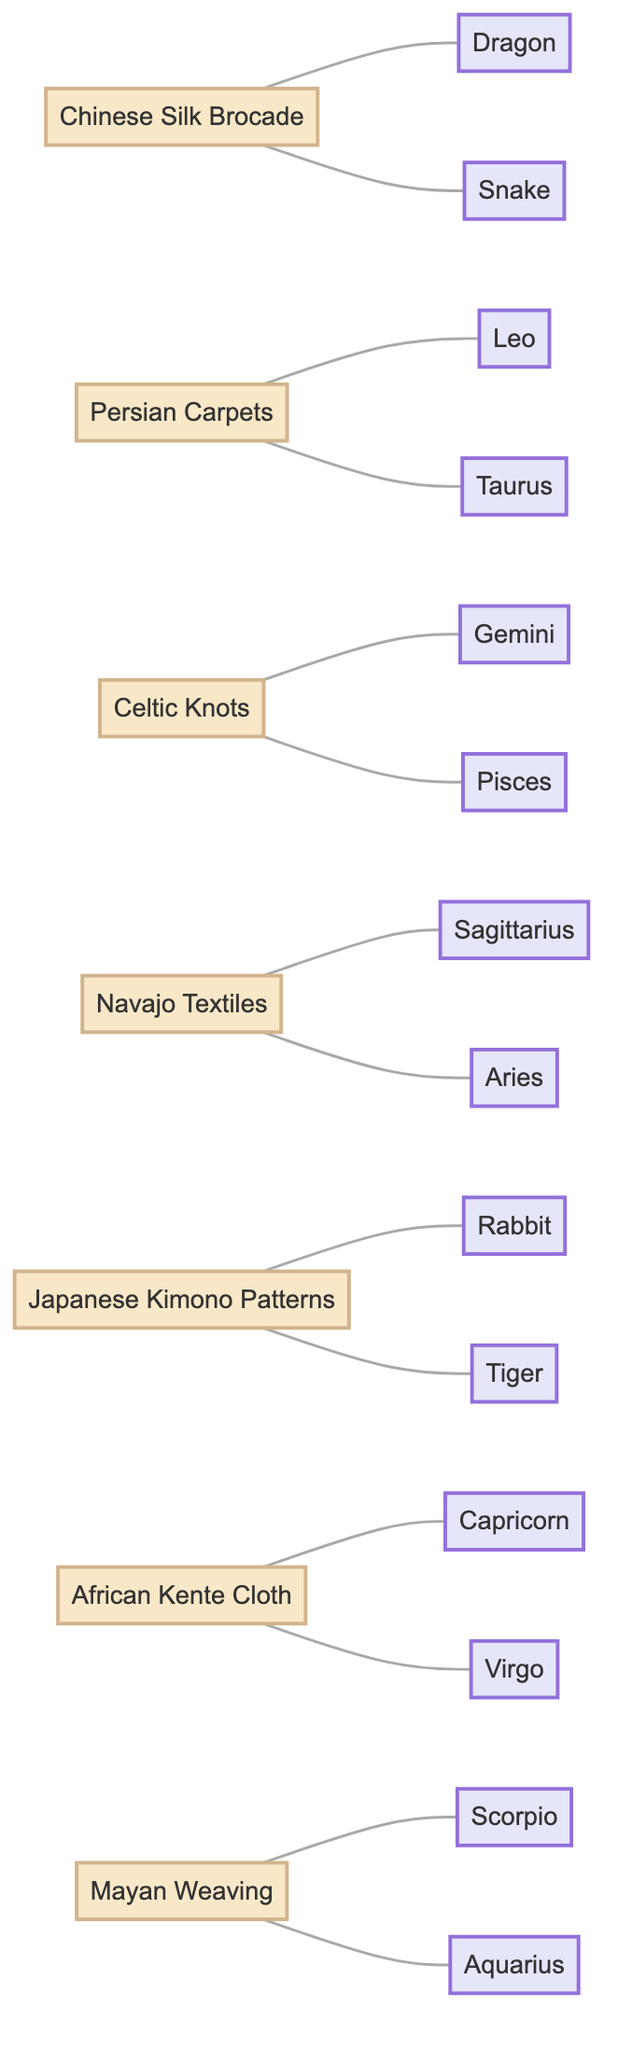What zodiac symbol is related to Chinese Silk Brocade? The diagram shows a connection between Chinese Silk Brocade and the zodiac symbols Dragon and Snake. Both are visually linked directly to the Chinese Silk Brocade node.
Answer: Dragon, Snake How many textile patterns are related to Taurus? The Taurus zodiac symbol is linked only to the Persian Carpets node in the diagram. Hence, there is just one textile pattern associated with Taurus.
Answer: 1 Which textile pattern is associated with Sagittarius? The diagram indicates that the Navajo Textiles node is directly connected to the Sagittarius zodiac symbol. This relationship tells us the specific textile pattern related to Sagittarius.
Answer: Navajo Textiles What is the total number of zodiac symbols in the diagram? By counting the zodiac nodes in the diagram, we find there are 14 unique zodiac symbols presented. This totals all the distinct nodes for zodiac signs displayed.
Answer: 14 Which two zodiac symbols connect to Celtic Knots? Inspecting the connections, we see that the Gemini and Pisces zodiac symbols are both connected to the Celtic Knots node. These connections are explicitly shown as edges in the diagram.
Answer: Gemini, Pisces What is the relationship between African Kente Cloth and zodiac symbols? The African Kente Cloth node is linked to Capricorn and Virgo, indicating that both zodiac symbols share a relationship with this particular textile pattern as seen in the diagram.
Answer: Capricorn, Virgo Which textile patterns are associated with Rabbit and Tiger symbols? Upon reviewing the connections, we identify that Japanese Kimono Patterns is the only textile pattern linked to both the Rabbit and Tiger zodiac symbols, showcasing this unique relationship.
Answer: Japanese Kimono Patterns How many edges connect to Mayan Weaving? Checking the diagram, Mayan Weaving has two edges connecting it to the Scorpio and Aquarius zodiac symbols, indicating its direct relationships with these signs.
Answer: 2 What textile pattern links with both Leo and Taurus? The Persian Carpets node shows a connection to both the Leo and Taurus zodiac symbols, demonstrating the intersection of this textile with these specific zodiac signs.
Answer: Persian Carpets 